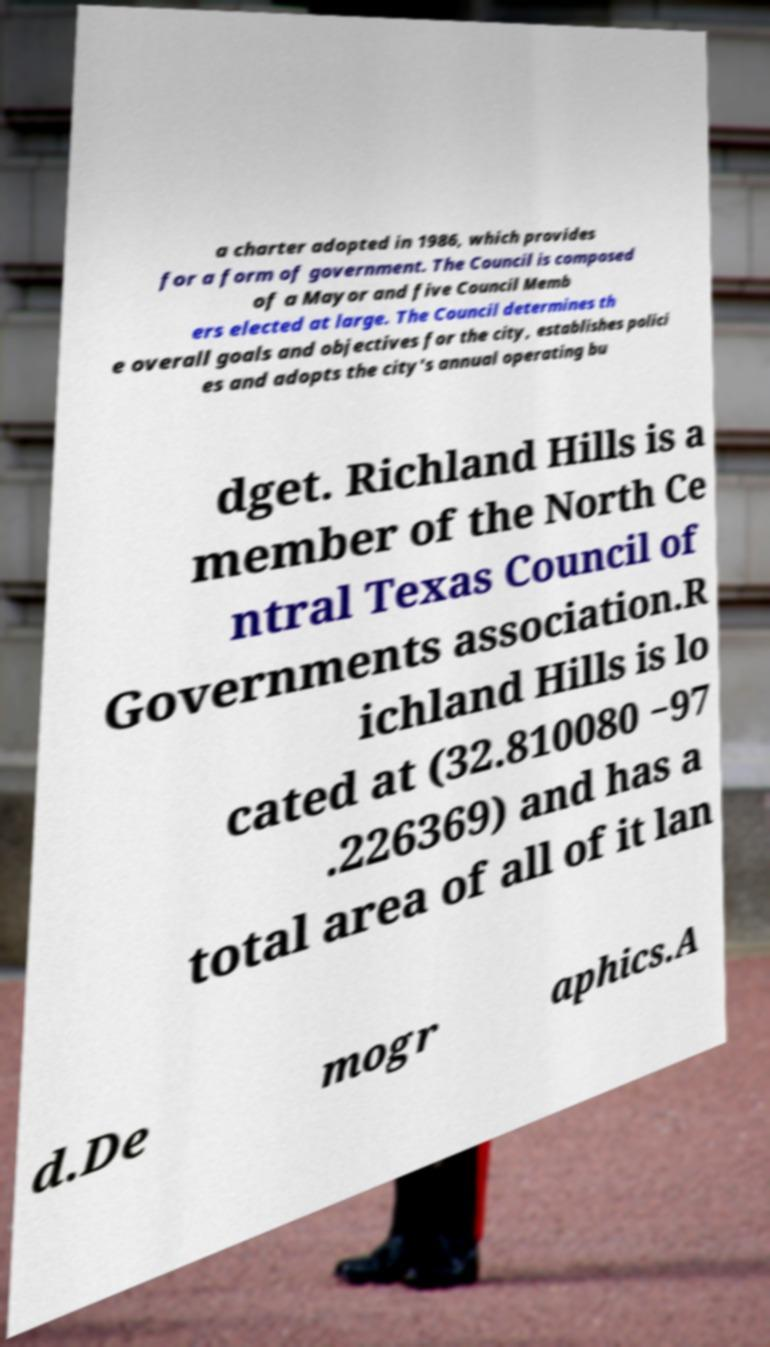Can you accurately transcribe the text from the provided image for me? a charter adopted in 1986, which provides for a form of government. The Council is composed of a Mayor and five Council Memb ers elected at large. The Council determines th e overall goals and objectives for the city, establishes polici es and adopts the city's annual operating bu dget. Richland Hills is a member of the North Ce ntral Texas Council of Governments association.R ichland Hills is lo cated at (32.810080 −97 .226369) and has a total area of all of it lan d.De mogr aphics.A 